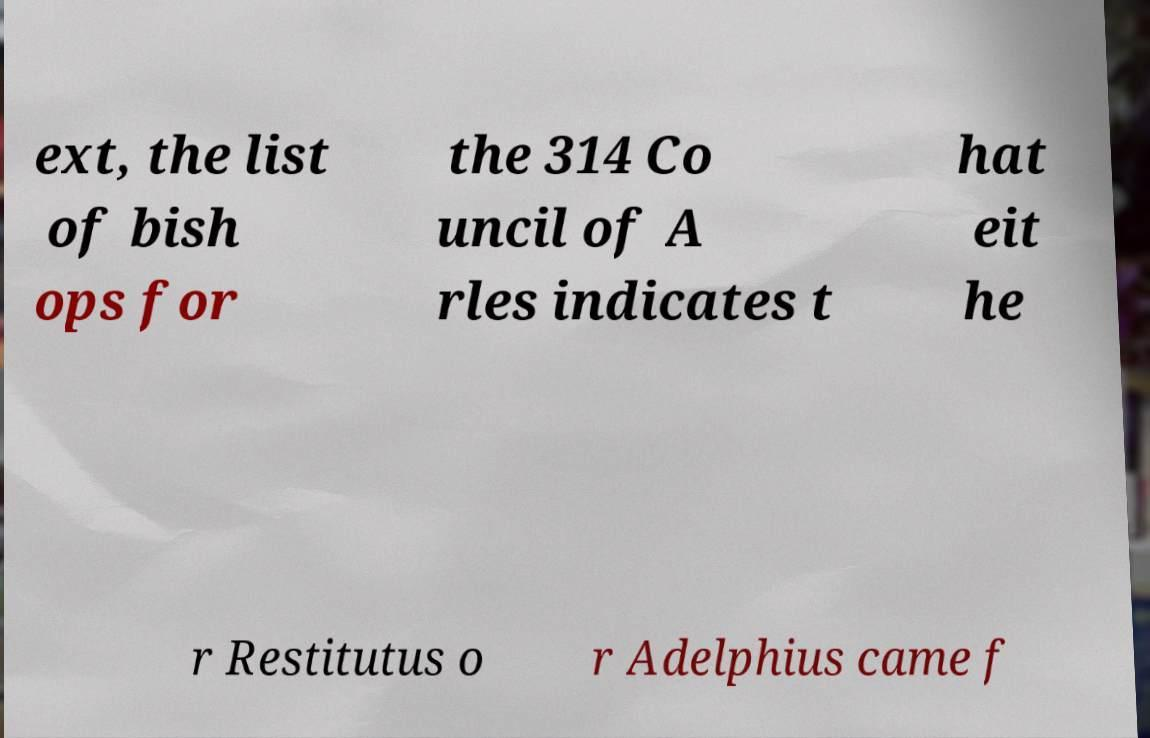Can you read and provide the text displayed in the image?This photo seems to have some interesting text. Can you extract and type it out for me? ext, the list of bish ops for the 314 Co uncil of A rles indicates t hat eit he r Restitutus o r Adelphius came f 